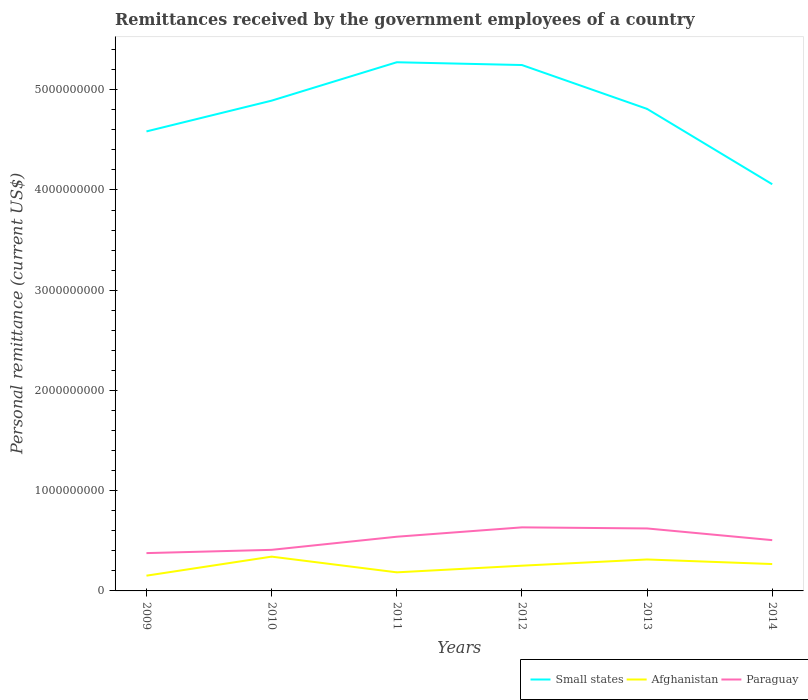How many different coloured lines are there?
Your answer should be compact. 3. Does the line corresponding to Small states intersect with the line corresponding to Paraguay?
Offer a very short reply. No. Across all years, what is the maximum remittances received by the government employees in Paraguay?
Your answer should be very brief. 3.77e+08. What is the total remittances received by the government employees in Small states in the graph?
Provide a succinct answer. 5.27e+08. What is the difference between the highest and the second highest remittances received by the government employees in Small states?
Your response must be concise. 1.22e+09. What is the difference between the highest and the lowest remittances received by the government employees in Afghanistan?
Offer a terse response. 3. How many years are there in the graph?
Your answer should be compact. 6. What is the difference between two consecutive major ticks on the Y-axis?
Give a very brief answer. 1.00e+09. Where does the legend appear in the graph?
Give a very brief answer. Bottom right. How many legend labels are there?
Your answer should be very brief. 3. How are the legend labels stacked?
Keep it short and to the point. Horizontal. What is the title of the graph?
Make the answer very short. Remittances received by the government employees of a country. What is the label or title of the X-axis?
Make the answer very short. Years. What is the label or title of the Y-axis?
Offer a very short reply. Personal remittance (current US$). What is the Personal remittance (current US$) of Small states in 2009?
Ensure brevity in your answer.  4.58e+09. What is the Personal remittance (current US$) of Afghanistan in 2009?
Ensure brevity in your answer.  1.52e+08. What is the Personal remittance (current US$) of Paraguay in 2009?
Offer a terse response. 3.77e+08. What is the Personal remittance (current US$) of Small states in 2010?
Offer a terse response. 4.89e+09. What is the Personal remittance (current US$) in Afghanistan in 2010?
Provide a succinct answer. 3.42e+08. What is the Personal remittance (current US$) of Paraguay in 2010?
Your answer should be compact. 4.10e+08. What is the Personal remittance (current US$) of Small states in 2011?
Your answer should be compact. 5.27e+09. What is the Personal remittance (current US$) in Afghanistan in 2011?
Offer a very short reply. 1.85e+08. What is the Personal remittance (current US$) in Paraguay in 2011?
Offer a terse response. 5.41e+08. What is the Personal remittance (current US$) of Small states in 2012?
Offer a very short reply. 5.25e+09. What is the Personal remittance (current US$) in Afghanistan in 2012?
Ensure brevity in your answer.  2.52e+08. What is the Personal remittance (current US$) in Paraguay in 2012?
Offer a very short reply. 6.34e+08. What is the Personal remittance (current US$) in Small states in 2013?
Make the answer very short. 4.81e+09. What is the Personal remittance (current US$) of Afghanistan in 2013?
Keep it short and to the point. 3.14e+08. What is the Personal remittance (current US$) of Paraguay in 2013?
Your answer should be compact. 6.23e+08. What is the Personal remittance (current US$) in Small states in 2014?
Keep it short and to the point. 4.06e+09. What is the Personal remittance (current US$) of Afghanistan in 2014?
Provide a short and direct response. 2.68e+08. What is the Personal remittance (current US$) of Paraguay in 2014?
Keep it short and to the point. 5.07e+08. Across all years, what is the maximum Personal remittance (current US$) in Small states?
Keep it short and to the point. 5.27e+09. Across all years, what is the maximum Personal remittance (current US$) in Afghanistan?
Make the answer very short. 3.42e+08. Across all years, what is the maximum Personal remittance (current US$) in Paraguay?
Give a very brief answer. 6.34e+08. Across all years, what is the minimum Personal remittance (current US$) of Small states?
Provide a short and direct response. 4.06e+09. Across all years, what is the minimum Personal remittance (current US$) in Afghanistan?
Keep it short and to the point. 1.52e+08. Across all years, what is the minimum Personal remittance (current US$) in Paraguay?
Provide a short and direct response. 3.77e+08. What is the total Personal remittance (current US$) in Small states in the graph?
Offer a very short reply. 2.89e+1. What is the total Personal remittance (current US$) in Afghanistan in the graph?
Your answer should be very brief. 1.51e+09. What is the total Personal remittance (current US$) in Paraguay in the graph?
Ensure brevity in your answer.  3.09e+09. What is the difference between the Personal remittance (current US$) in Small states in 2009 and that in 2010?
Give a very brief answer. -3.07e+08. What is the difference between the Personal remittance (current US$) of Afghanistan in 2009 and that in 2010?
Provide a short and direct response. -1.90e+08. What is the difference between the Personal remittance (current US$) of Paraguay in 2009 and that in 2010?
Ensure brevity in your answer.  -3.26e+07. What is the difference between the Personal remittance (current US$) of Small states in 2009 and that in 2011?
Your answer should be very brief. -6.90e+08. What is the difference between the Personal remittance (current US$) of Afghanistan in 2009 and that in 2011?
Provide a succinct answer. -3.31e+07. What is the difference between the Personal remittance (current US$) in Paraguay in 2009 and that in 2011?
Offer a very short reply. -1.63e+08. What is the difference between the Personal remittance (current US$) of Small states in 2009 and that in 2012?
Offer a very short reply. -6.62e+08. What is the difference between the Personal remittance (current US$) of Afghanistan in 2009 and that in 2012?
Provide a short and direct response. -9.95e+07. What is the difference between the Personal remittance (current US$) of Paraguay in 2009 and that in 2012?
Offer a very short reply. -2.57e+08. What is the difference between the Personal remittance (current US$) in Small states in 2009 and that in 2013?
Keep it short and to the point. -2.25e+08. What is the difference between the Personal remittance (current US$) of Afghanistan in 2009 and that in 2013?
Make the answer very short. -1.62e+08. What is the difference between the Personal remittance (current US$) in Paraguay in 2009 and that in 2013?
Provide a short and direct response. -2.46e+08. What is the difference between the Personal remittance (current US$) in Small states in 2009 and that in 2014?
Make the answer very short. 5.27e+08. What is the difference between the Personal remittance (current US$) in Afghanistan in 2009 and that in 2014?
Offer a terse response. -1.16e+08. What is the difference between the Personal remittance (current US$) in Paraguay in 2009 and that in 2014?
Provide a short and direct response. -1.29e+08. What is the difference between the Personal remittance (current US$) of Small states in 2010 and that in 2011?
Your answer should be compact. -3.83e+08. What is the difference between the Personal remittance (current US$) in Afghanistan in 2010 and that in 2011?
Your answer should be very brief. 1.57e+08. What is the difference between the Personal remittance (current US$) in Paraguay in 2010 and that in 2011?
Your answer should be very brief. -1.31e+08. What is the difference between the Personal remittance (current US$) in Small states in 2010 and that in 2012?
Offer a terse response. -3.55e+08. What is the difference between the Personal remittance (current US$) of Afghanistan in 2010 and that in 2012?
Provide a succinct answer. 9.03e+07. What is the difference between the Personal remittance (current US$) of Paraguay in 2010 and that in 2012?
Give a very brief answer. -2.24e+08. What is the difference between the Personal remittance (current US$) of Small states in 2010 and that in 2013?
Keep it short and to the point. 8.22e+07. What is the difference between the Personal remittance (current US$) of Afghanistan in 2010 and that in 2013?
Provide a short and direct response. 2.83e+07. What is the difference between the Personal remittance (current US$) of Paraguay in 2010 and that in 2013?
Your response must be concise. -2.13e+08. What is the difference between the Personal remittance (current US$) of Small states in 2010 and that in 2014?
Keep it short and to the point. 8.34e+08. What is the difference between the Personal remittance (current US$) in Afghanistan in 2010 and that in 2014?
Offer a very short reply. 7.40e+07. What is the difference between the Personal remittance (current US$) of Paraguay in 2010 and that in 2014?
Your response must be concise. -9.68e+07. What is the difference between the Personal remittance (current US$) of Small states in 2011 and that in 2012?
Provide a succinct answer. 2.77e+07. What is the difference between the Personal remittance (current US$) of Afghanistan in 2011 and that in 2012?
Your answer should be compact. -6.64e+07. What is the difference between the Personal remittance (current US$) of Paraguay in 2011 and that in 2012?
Your response must be concise. -9.34e+07. What is the difference between the Personal remittance (current US$) of Small states in 2011 and that in 2013?
Ensure brevity in your answer.  4.65e+08. What is the difference between the Personal remittance (current US$) in Afghanistan in 2011 and that in 2013?
Offer a very short reply. -1.28e+08. What is the difference between the Personal remittance (current US$) in Paraguay in 2011 and that in 2013?
Offer a very short reply. -8.26e+07. What is the difference between the Personal remittance (current US$) in Small states in 2011 and that in 2014?
Provide a short and direct response. 1.22e+09. What is the difference between the Personal remittance (current US$) in Afghanistan in 2011 and that in 2014?
Your answer should be very brief. -8.27e+07. What is the difference between the Personal remittance (current US$) in Paraguay in 2011 and that in 2014?
Ensure brevity in your answer.  3.40e+07. What is the difference between the Personal remittance (current US$) of Small states in 2012 and that in 2013?
Make the answer very short. 4.38e+08. What is the difference between the Personal remittance (current US$) of Afghanistan in 2012 and that in 2013?
Your answer should be very brief. -6.20e+07. What is the difference between the Personal remittance (current US$) in Paraguay in 2012 and that in 2013?
Your response must be concise. 1.08e+07. What is the difference between the Personal remittance (current US$) in Small states in 2012 and that in 2014?
Your answer should be very brief. 1.19e+09. What is the difference between the Personal remittance (current US$) in Afghanistan in 2012 and that in 2014?
Provide a short and direct response. -1.63e+07. What is the difference between the Personal remittance (current US$) in Paraguay in 2012 and that in 2014?
Make the answer very short. 1.27e+08. What is the difference between the Personal remittance (current US$) of Small states in 2013 and that in 2014?
Your answer should be very brief. 7.52e+08. What is the difference between the Personal remittance (current US$) in Afghanistan in 2013 and that in 2014?
Offer a terse response. 4.57e+07. What is the difference between the Personal remittance (current US$) of Paraguay in 2013 and that in 2014?
Provide a succinct answer. 1.17e+08. What is the difference between the Personal remittance (current US$) of Small states in 2009 and the Personal remittance (current US$) of Afghanistan in 2010?
Offer a very short reply. 4.24e+09. What is the difference between the Personal remittance (current US$) in Small states in 2009 and the Personal remittance (current US$) in Paraguay in 2010?
Provide a short and direct response. 4.17e+09. What is the difference between the Personal remittance (current US$) of Afghanistan in 2009 and the Personal remittance (current US$) of Paraguay in 2010?
Ensure brevity in your answer.  -2.58e+08. What is the difference between the Personal remittance (current US$) in Small states in 2009 and the Personal remittance (current US$) in Afghanistan in 2011?
Provide a short and direct response. 4.40e+09. What is the difference between the Personal remittance (current US$) of Small states in 2009 and the Personal remittance (current US$) of Paraguay in 2011?
Ensure brevity in your answer.  4.04e+09. What is the difference between the Personal remittance (current US$) in Afghanistan in 2009 and the Personal remittance (current US$) in Paraguay in 2011?
Offer a very short reply. -3.88e+08. What is the difference between the Personal remittance (current US$) of Small states in 2009 and the Personal remittance (current US$) of Afghanistan in 2012?
Your response must be concise. 4.33e+09. What is the difference between the Personal remittance (current US$) of Small states in 2009 and the Personal remittance (current US$) of Paraguay in 2012?
Keep it short and to the point. 3.95e+09. What is the difference between the Personal remittance (current US$) in Afghanistan in 2009 and the Personal remittance (current US$) in Paraguay in 2012?
Provide a short and direct response. -4.82e+08. What is the difference between the Personal remittance (current US$) of Small states in 2009 and the Personal remittance (current US$) of Afghanistan in 2013?
Your answer should be compact. 4.27e+09. What is the difference between the Personal remittance (current US$) of Small states in 2009 and the Personal remittance (current US$) of Paraguay in 2013?
Your response must be concise. 3.96e+09. What is the difference between the Personal remittance (current US$) of Afghanistan in 2009 and the Personal remittance (current US$) of Paraguay in 2013?
Make the answer very short. -4.71e+08. What is the difference between the Personal remittance (current US$) of Small states in 2009 and the Personal remittance (current US$) of Afghanistan in 2014?
Provide a succinct answer. 4.32e+09. What is the difference between the Personal remittance (current US$) of Small states in 2009 and the Personal remittance (current US$) of Paraguay in 2014?
Provide a succinct answer. 4.08e+09. What is the difference between the Personal remittance (current US$) of Afghanistan in 2009 and the Personal remittance (current US$) of Paraguay in 2014?
Your answer should be very brief. -3.54e+08. What is the difference between the Personal remittance (current US$) in Small states in 2010 and the Personal remittance (current US$) in Afghanistan in 2011?
Provide a short and direct response. 4.71e+09. What is the difference between the Personal remittance (current US$) of Small states in 2010 and the Personal remittance (current US$) of Paraguay in 2011?
Your answer should be compact. 4.35e+09. What is the difference between the Personal remittance (current US$) of Afghanistan in 2010 and the Personal remittance (current US$) of Paraguay in 2011?
Offer a very short reply. -1.99e+08. What is the difference between the Personal remittance (current US$) of Small states in 2010 and the Personal remittance (current US$) of Afghanistan in 2012?
Provide a short and direct response. 4.64e+09. What is the difference between the Personal remittance (current US$) of Small states in 2010 and the Personal remittance (current US$) of Paraguay in 2012?
Offer a very short reply. 4.26e+09. What is the difference between the Personal remittance (current US$) of Afghanistan in 2010 and the Personal remittance (current US$) of Paraguay in 2012?
Provide a short and direct response. -2.92e+08. What is the difference between the Personal remittance (current US$) of Small states in 2010 and the Personal remittance (current US$) of Afghanistan in 2013?
Ensure brevity in your answer.  4.58e+09. What is the difference between the Personal remittance (current US$) of Small states in 2010 and the Personal remittance (current US$) of Paraguay in 2013?
Make the answer very short. 4.27e+09. What is the difference between the Personal remittance (current US$) of Afghanistan in 2010 and the Personal remittance (current US$) of Paraguay in 2013?
Keep it short and to the point. -2.81e+08. What is the difference between the Personal remittance (current US$) of Small states in 2010 and the Personal remittance (current US$) of Afghanistan in 2014?
Your answer should be compact. 4.62e+09. What is the difference between the Personal remittance (current US$) in Small states in 2010 and the Personal remittance (current US$) in Paraguay in 2014?
Your answer should be compact. 4.38e+09. What is the difference between the Personal remittance (current US$) in Afghanistan in 2010 and the Personal remittance (current US$) in Paraguay in 2014?
Provide a succinct answer. -1.65e+08. What is the difference between the Personal remittance (current US$) of Small states in 2011 and the Personal remittance (current US$) of Afghanistan in 2012?
Provide a succinct answer. 5.02e+09. What is the difference between the Personal remittance (current US$) in Small states in 2011 and the Personal remittance (current US$) in Paraguay in 2012?
Provide a succinct answer. 4.64e+09. What is the difference between the Personal remittance (current US$) in Afghanistan in 2011 and the Personal remittance (current US$) in Paraguay in 2012?
Give a very brief answer. -4.49e+08. What is the difference between the Personal remittance (current US$) of Small states in 2011 and the Personal remittance (current US$) of Afghanistan in 2013?
Your answer should be compact. 4.96e+09. What is the difference between the Personal remittance (current US$) in Small states in 2011 and the Personal remittance (current US$) in Paraguay in 2013?
Offer a terse response. 4.65e+09. What is the difference between the Personal remittance (current US$) of Afghanistan in 2011 and the Personal remittance (current US$) of Paraguay in 2013?
Your answer should be compact. -4.38e+08. What is the difference between the Personal remittance (current US$) in Small states in 2011 and the Personal remittance (current US$) in Afghanistan in 2014?
Your answer should be very brief. 5.01e+09. What is the difference between the Personal remittance (current US$) of Small states in 2011 and the Personal remittance (current US$) of Paraguay in 2014?
Your response must be concise. 4.77e+09. What is the difference between the Personal remittance (current US$) of Afghanistan in 2011 and the Personal remittance (current US$) of Paraguay in 2014?
Provide a short and direct response. -3.21e+08. What is the difference between the Personal remittance (current US$) of Small states in 2012 and the Personal remittance (current US$) of Afghanistan in 2013?
Your answer should be very brief. 4.93e+09. What is the difference between the Personal remittance (current US$) of Small states in 2012 and the Personal remittance (current US$) of Paraguay in 2013?
Your answer should be compact. 4.62e+09. What is the difference between the Personal remittance (current US$) of Afghanistan in 2012 and the Personal remittance (current US$) of Paraguay in 2013?
Give a very brief answer. -3.72e+08. What is the difference between the Personal remittance (current US$) in Small states in 2012 and the Personal remittance (current US$) in Afghanistan in 2014?
Make the answer very short. 4.98e+09. What is the difference between the Personal remittance (current US$) of Small states in 2012 and the Personal remittance (current US$) of Paraguay in 2014?
Keep it short and to the point. 4.74e+09. What is the difference between the Personal remittance (current US$) of Afghanistan in 2012 and the Personal remittance (current US$) of Paraguay in 2014?
Give a very brief answer. -2.55e+08. What is the difference between the Personal remittance (current US$) in Small states in 2013 and the Personal remittance (current US$) in Afghanistan in 2014?
Offer a very short reply. 4.54e+09. What is the difference between the Personal remittance (current US$) in Small states in 2013 and the Personal remittance (current US$) in Paraguay in 2014?
Make the answer very short. 4.30e+09. What is the difference between the Personal remittance (current US$) of Afghanistan in 2013 and the Personal remittance (current US$) of Paraguay in 2014?
Offer a terse response. -1.93e+08. What is the average Personal remittance (current US$) of Small states per year?
Offer a terse response. 4.81e+09. What is the average Personal remittance (current US$) in Afghanistan per year?
Ensure brevity in your answer.  2.52e+08. What is the average Personal remittance (current US$) in Paraguay per year?
Your response must be concise. 5.15e+08. In the year 2009, what is the difference between the Personal remittance (current US$) in Small states and Personal remittance (current US$) in Afghanistan?
Ensure brevity in your answer.  4.43e+09. In the year 2009, what is the difference between the Personal remittance (current US$) of Small states and Personal remittance (current US$) of Paraguay?
Your answer should be very brief. 4.21e+09. In the year 2009, what is the difference between the Personal remittance (current US$) in Afghanistan and Personal remittance (current US$) in Paraguay?
Provide a short and direct response. -2.25e+08. In the year 2010, what is the difference between the Personal remittance (current US$) in Small states and Personal remittance (current US$) in Afghanistan?
Give a very brief answer. 4.55e+09. In the year 2010, what is the difference between the Personal remittance (current US$) of Small states and Personal remittance (current US$) of Paraguay?
Ensure brevity in your answer.  4.48e+09. In the year 2010, what is the difference between the Personal remittance (current US$) in Afghanistan and Personal remittance (current US$) in Paraguay?
Your response must be concise. -6.78e+07. In the year 2011, what is the difference between the Personal remittance (current US$) in Small states and Personal remittance (current US$) in Afghanistan?
Keep it short and to the point. 5.09e+09. In the year 2011, what is the difference between the Personal remittance (current US$) in Small states and Personal remittance (current US$) in Paraguay?
Ensure brevity in your answer.  4.73e+09. In the year 2011, what is the difference between the Personal remittance (current US$) in Afghanistan and Personal remittance (current US$) in Paraguay?
Provide a short and direct response. -3.55e+08. In the year 2012, what is the difference between the Personal remittance (current US$) of Small states and Personal remittance (current US$) of Afghanistan?
Keep it short and to the point. 4.99e+09. In the year 2012, what is the difference between the Personal remittance (current US$) in Small states and Personal remittance (current US$) in Paraguay?
Give a very brief answer. 4.61e+09. In the year 2012, what is the difference between the Personal remittance (current US$) in Afghanistan and Personal remittance (current US$) in Paraguay?
Make the answer very short. -3.82e+08. In the year 2013, what is the difference between the Personal remittance (current US$) of Small states and Personal remittance (current US$) of Afghanistan?
Your answer should be compact. 4.50e+09. In the year 2013, what is the difference between the Personal remittance (current US$) of Small states and Personal remittance (current US$) of Paraguay?
Provide a short and direct response. 4.19e+09. In the year 2013, what is the difference between the Personal remittance (current US$) of Afghanistan and Personal remittance (current US$) of Paraguay?
Your answer should be compact. -3.10e+08. In the year 2014, what is the difference between the Personal remittance (current US$) of Small states and Personal remittance (current US$) of Afghanistan?
Offer a terse response. 3.79e+09. In the year 2014, what is the difference between the Personal remittance (current US$) of Small states and Personal remittance (current US$) of Paraguay?
Make the answer very short. 3.55e+09. In the year 2014, what is the difference between the Personal remittance (current US$) of Afghanistan and Personal remittance (current US$) of Paraguay?
Offer a terse response. -2.39e+08. What is the ratio of the Personal remittance (current US$) of Small states in 2009 to that in 2010?
Make the answer very short. 0.94. What is the ratio of the Personal remittance (current US$) in Afghanistan in 2009 to that in 2010?
Offer a very short reply. 0.45. What is the ratio of the Personal remittance (current US$) in Paraguay in 2009 to that in 2010?
Your answer should be very brief. 0.92. What is the ratio of the Personal remittance (current US$) in Small states in 2009 to that in 2011?
Keep it short and to the point. 0.87. What is the ratio of the Personal remittance (current US$) in Afghanistan in 2009 to that in 2011?
Make the answer very short. 0.82. What is the ratio of the Personal remittance (current US$) of Paraguay in 2009 to that in 2011?
Give a very brief answer. 0.7. What is the ratio of the Personal remittance (current US$) in Small states in 2009 to that in 2012?
Provide a short and direct response. 0.87. What is the ratio of the Personal remittance (current US$) of Afghanistan in 2009 to that in 2012?
Make the answer very short. 0.6. What is the ratio of the Personal remittance (current US$) in Paraguay in 2009 to that in 2012?
Offer a very short reply. 0.59. What is the ratio of the Personal remittance (current US$) in Small states in 2009 to that in 2013?
Ensure brevity in your answer.  0.95. What is the ratio of the Personal remittance (current US$) in Afghanistan in 2009 to that in 2013?
Make the answer very short. 0.49. What is the ratio of the Personal remittance (current US$) of Paraguay in 2009 to that in 2013?
Your answer should be compact. 0.61. What is the ratio of the Personal remittance (current US$) of Small states in 2009 to that in 2014?
Ensure brevity in your answer.  1.13. What is the ratio of the Personal remittance (current US$) in Afghanistan in 2009 to that in 2014?
Your answer should be compact. 0.57. What is the ratio of the Personal remittance (current US$) in Paraguay in 2009 to that in 2014?
Your response must be concise. 0.74. What is the ratio of the Personal remittance (current US$) of Small states in 2010 to that in 2011?
Ensure brevity in your answer.  0.93. What is the ratio of the Personal remittance (current US$) in Afghanistan in 2010 to that in 2011?
Ensure brevity in your answer.  1.85. What is the ratio of the Personal remittance (current US$) of Paraguay in 2010 to that in 2011?
Your answer should be compact. 0.76. What is the ratio of the Personal remittance (current US$) in Small states in 2010 to that in 2012?
Your response must be concise. 0.93. What is the ratio of the Personal remittance (current US$) in Afghanistan in 2010 to that in 2012?
Provide a short and direct response. 1.36. What is the ratio of the Personal remittance (current US$) of Paraguay in 2010 to that in 2012?
Ensure brevity in your answer.  0.65. What is the ratio of the Personal remittance (current US$) in Small states in 2010 to that in 2013?
Ensure brevity in your answer.  1.02. What is the ratio of the Personal remittance (current US$) of Afghanistan in 2010 to that in 2013?
Keep it short and to the point. 1.09. What is the ratio of the Personal remittance (current US$) in Paraguay in 2010 to that in 2013?
Your response must be concise. 0.66. What is the ratio of the Personal remittance (current US$) in Small states in 2010 to that in 2014?
Your answer should be very brief. 1.21. What is the ratio of the Personal remittance (current US$) of Afghanistan in 2010 to that in 2014?
Give a very brief answer. 1.28. What is the ratio of the Personal remittance (current US$) of Paraguay in 2010 to that in 2014?
Your answer should be compact. 0.81. What is the ratio of the Personal remittance (current US$) in Afghanistan in 2011 to that in 2012?
Your answer should be very brief. 0.74. What is the ratio of the Personal remittance (current US$) of Paraguay in 2011 to that in 2012?
Offer a very short reply. 0.85. What is the ratio of the Personal remittance (current US$) of Small states in 2011 to that in 2013?
Offer a terse response. 1.1. What is the ratio of the Personal remittance (current US$) in Afghanistan in 2011 to that in 2013?
Provide a succinct answer. 0.59. What is the ratio of the Personal remittance (current US$) in Paraguay in 2011 to that in 2013?
Keep it short and to the point. 0.87. What is the ratio of the Personal remittance (current US$) of Small states in 2011 to that in 2014?
Your answer should be compact. 1.3. What is the ratio of the Personal remittance (current US$) in Afghanistan in 2011 to that in 2014?
Offer a very short reply. 0.69. What is the ratio of the Personal remittance (current US$) of Paraguay in 2011 to that in 2014?
Your answer should be compact. 1.07. What is the ratio of the Personal remittance (current US$) of Small states in 2012 to that in 2013?
Ensure brevity in your answer.  1.09. What is the ratio of the Personal remittance (current US$) in Afghanistan in 2012 to that in 2013?
Offer a terse response. 0.8. What is the ratio of the Personal remittance (current US$) of Paraguay in 2012 to that in 2013?
Provide a succinct answer. 1.02. What is the ratio of the Personal remittance (current US$) of Small states in 2012 to that in 2014?
Your response must be concise. 1.29. What is the ratio of the Personal remittance (current US$) of Afghanistan in 2012 to that in 2014?
Your answer should be compact. 0.94. What is the ratio of the Personal remittance (current US$) of Paraguay in 2012 to that in 2014?
Your answer should be very brief. 1.25. What is the ratio of the Personal remittance (current US$) in Small states in 2013 to that in 2014?
Offer a very short reply. 1.19. What is the ratio of the Personal remittance (current US$) in Afghanistan in 2013 to that in 2014?
Provide a short and direct response. 1.17. What is the ratio of the Personal remittance (current US$) of Paraguay in 2013 to that in 2014?
Your answer should be compact. 1.23. What is the difference between the highest and the second highest Personal remittance (current US$) in Small states?
Offer a very short reply. 2.77e+07. What is the difference between the highest and the second highest Personal remittance (current US$) in Afghanistan?
Offer a terse response. 2.83e+07. What is the difference between the highest and the second highest Personal remittance (current US$) in Paraguay?
Provide a short and direct response. 1.08e+07. What is the difference between the highest and the lowest Personal remittance (current US$) of Small states?
Your response must be concise. 1.22e+09. What is the difference between the highest and the lowest Personal remittance (current US$) of Afghanistan?
Your response must be concise. 1.90e+08. What is the difference between the highest and the lowest Personal remittance (current US$) in Paraguay?
Offer a very short reply. 2.57e+08. 